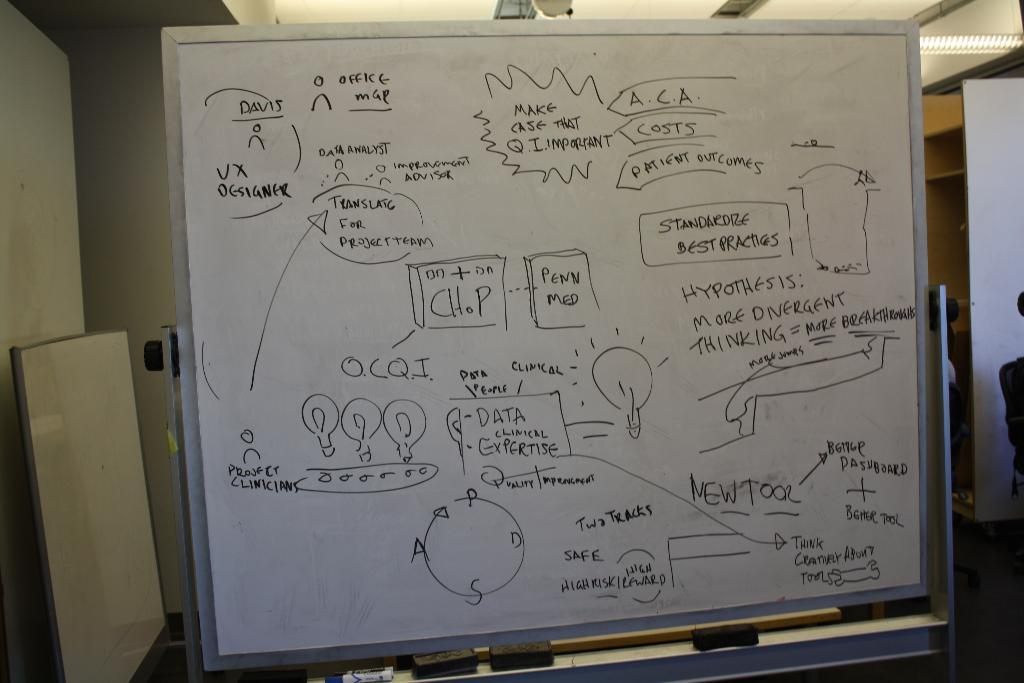<image>
Offer a succinct explanation of the picture presented. A white board with ideas on how to prove a hypothesis. 